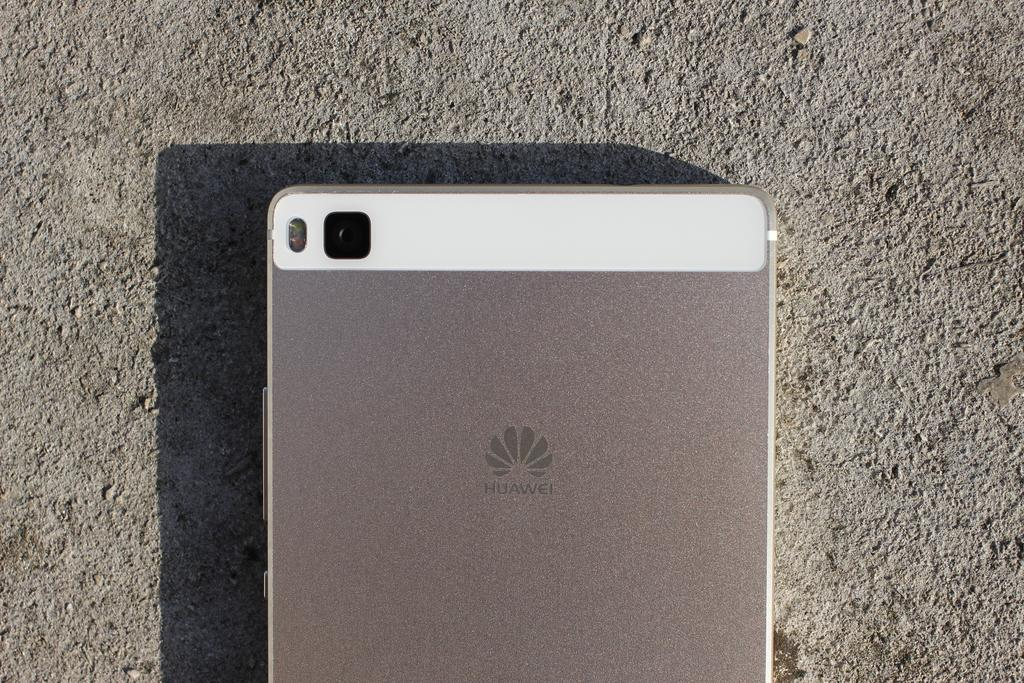<image>
Summarize the visual content of the image. A Huawei phone is screen down on pavement. 